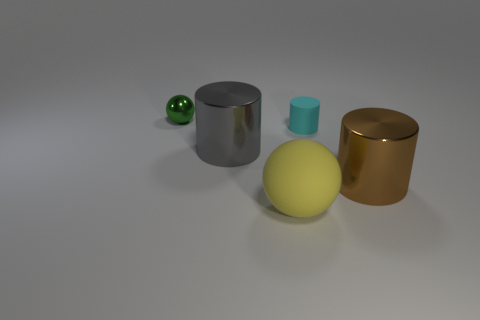What number of other objects are the same color as the metallic ball?
Your answer should be very brief. 0. Is the number of large yellow balls behind the small green shiny thing greater than the number of yellow objects behind the brown metal cylinder?
Your answer should be compact. No. The gray metallic object that is the same size as the brown thing is what shape?
Your response must be concise. Cylinder. How many things are small cyan things or big metallic cylinders to the right of the cyan cylinder?
Ensure brevity in your answer.  2. Does the big matte ball have the same color as the tiny cylinder?
Your answer should be very brief. No. There is a tiny green metallic sphere; how many small green spheres are behind it?
Your answer should be compact. 0. What is the color of the other cylinder that is made of the same material as the big gray cylinder?
Offer a terse response. Brown. How many metallic things are large brown objects or large things?
Provide a succinct answer. 2. Is the material of the big yellow sphere the same as the small ball?
Provide a succinct answer. No. There is a matte thing that is behind the big ball; what shape is it?
Ensure brevity in your answer.  Cylinder. 